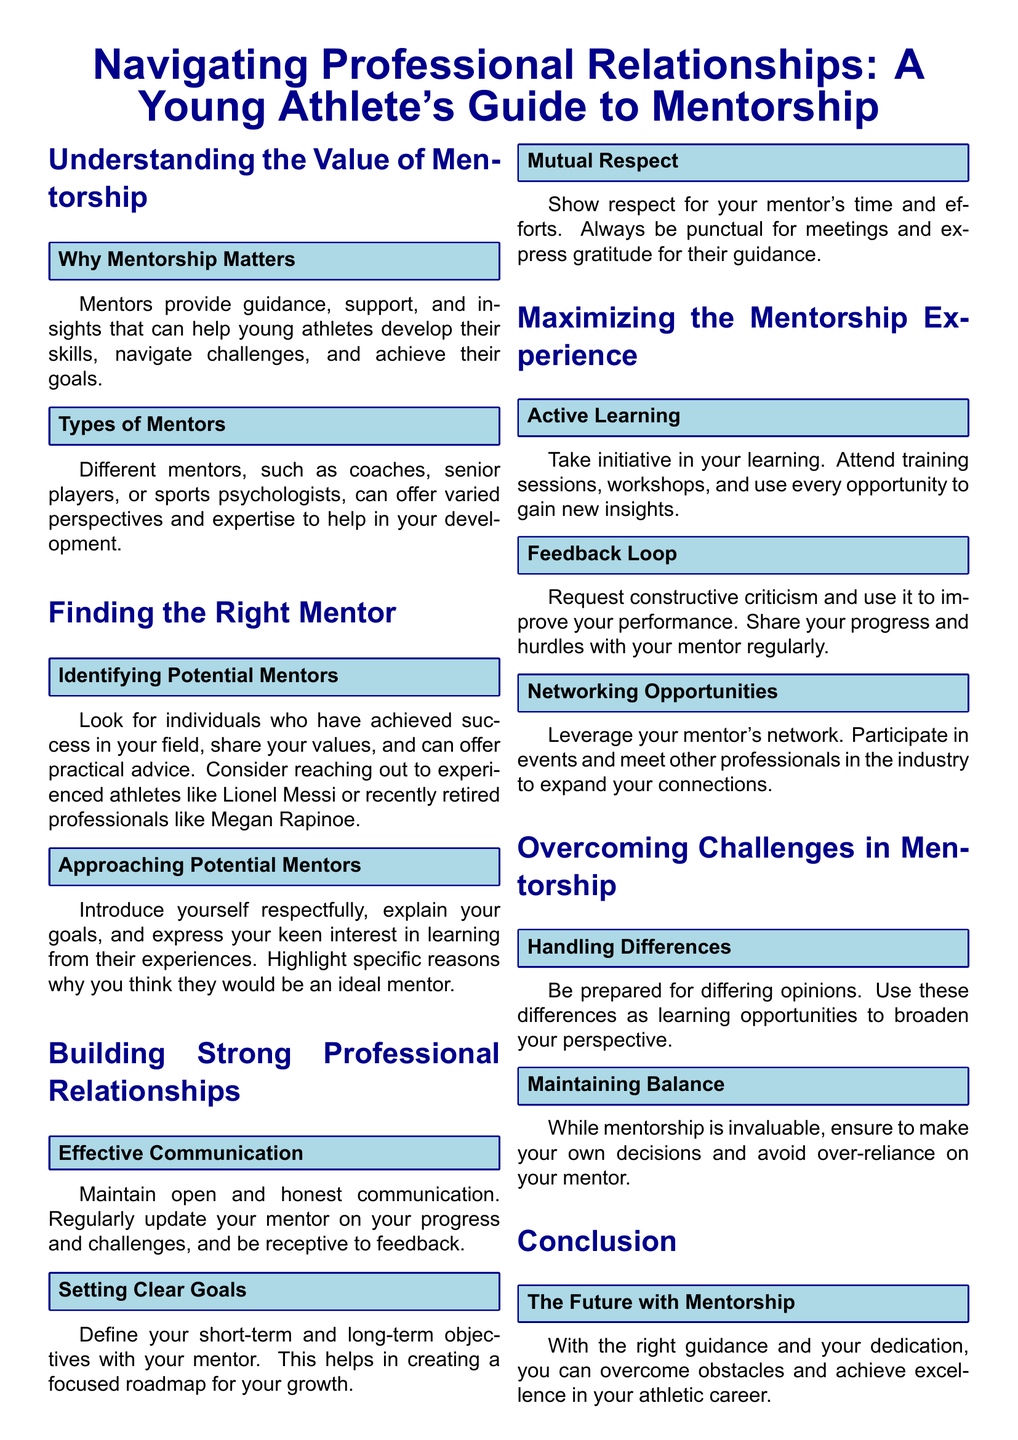What is the title of the guide? The title of the guide is presented at the top of the document and indicates its focus on mentorship for young athletes.
Answer: Navigating Professional Relationships: A Young Athlete's Guide to Mentorship Who can be considered potential mentors? The document lists individuals such as successful athletes and recently retired professionals as potential mentors for young athletes.
Answer: Lionel Messi, Megan Rapinoe What should be maintained for effective communication? The guide emphasizes that maintaining a specific form of communication is essential for creating a strong mentorship relationship.
Answer: Open and honest communication What is one approach to thank your mentor? The guide suggests expressing gratitude as a way to show respect and appreciation for a mentor's support and guidance.
Answer: Express gratitude What is the main purpose of mentorship according to the guide? The guide outlines the fundamental role of mentors in supporting the growth and development of young athletes.
Answer: Guidance, support, and insights How should you deal with differing opinions from your mentor? The document advises that differences should be viewed positively and used as a means of learning.
Answer: Use as learning opportunities What is recommended for maximizing your mentorship experience? The guide suggests a strategy for enhancing the benefits gained from mentorship through proactive involvement.
Answer: Active learning What is emphasized to maintain during the mentorship process? The guide highlights the importance of maintaining personal autonomy and decision-making while benefiting from mentorship.
Answer: Maintaining balance 